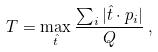Convert formula to latex. <formula><loc_0><loc_0><loc_500><loc_500>T = \max _ { \hat { t } } \frac { \sum _ { i } | \hat { t } \cdot { p } _ { i } | } { Q } \, ,</formula> 